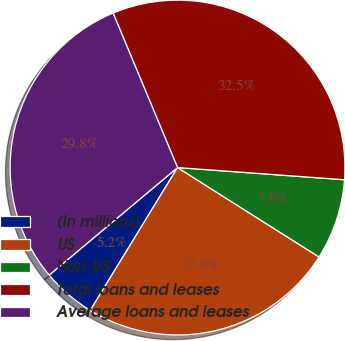Convert chart to OTSL. <chart><loc_0><loc_0><loc_500><loc_500><pie_chart><fcel>(In millions)<fcel>US<fcel>Non-US<fcel>Total loans and leases<fcel>Average loans and leases<nl><fcel>5.17%<fcel>24.76%<fcel>7.81%<fcel>32.45%<fcel>29.81%<nl></chart> 